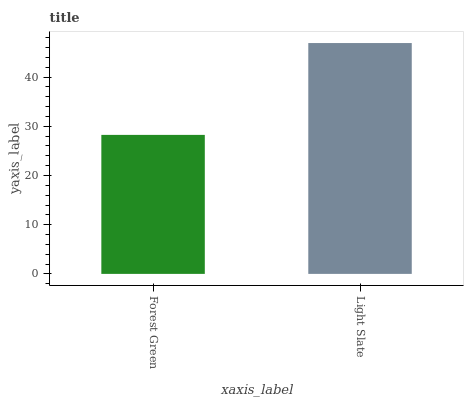Is Forest Green the minimum?
Answer yes or no. Yes. Is Light Slate the maximum?
Answer yes or no. Yes. Is Light Slate the minimum?
Answer yes or no. No. Is Light Slate greater than Forest Green?
Answer yes or no. Yes. Is Forest Green less than Light Slate?
Answer yes or no. Yes. Is Forest Green greater than Light Slate?
Answer yes or no. No. Is Light Slate less than Forest Green?
Answer yes or no. No. Is Light Slate the high median?
Answer yes or no. Yes. Is Forest Green the low median?
Answer yes or no. Yes. Is Forest Green the high median?
Answer yes or no. No. Is Light Slate the low median?
Answer yes or no. No. 